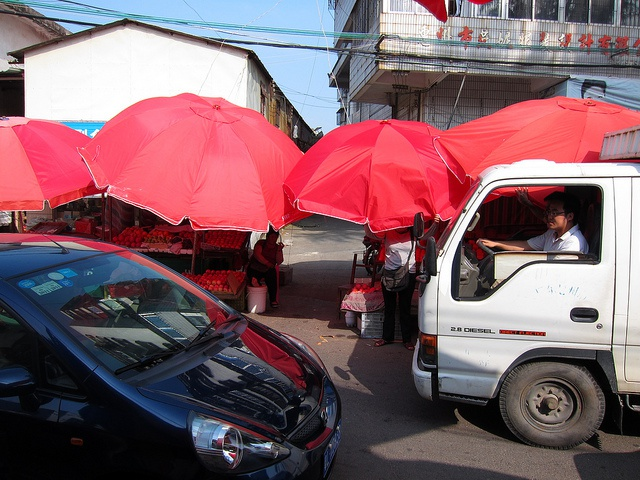Describe the objects in this image and their specific colors. I can see car in purple, black, navy, gray, and blue tones, truck in purple, white, black, gray, and darkgray tones, umbrella in purple, salmon, lightpink, and red tones, umbrella in purple, red, salmon, and brown tones, and umbrella in purple, salmon, red, and brown tones in this image. 